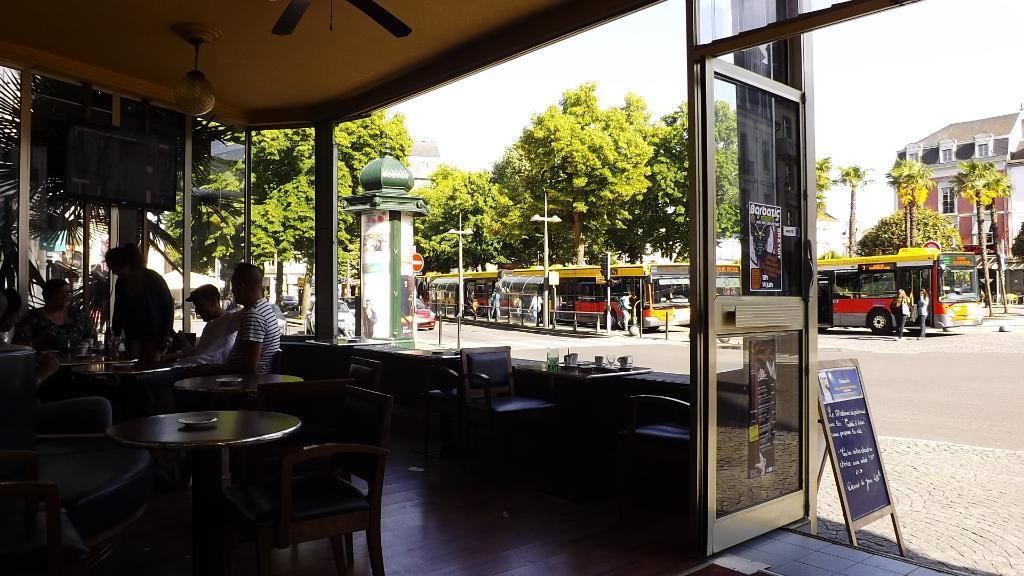How many people are in the image? There is a group of people in the image. What are the people doing in the image? The people are seated on chairs. How many chairs are visible in the image? There are chairs visible in the image. What type of furniture is also present in the image? There are tables in the image. What type of vegetation can be seen in the image? Bushes and trees are visible in the image. What type of structure is present in the image? There is a building in the image. How many elbows can be seen on the people in the image? There is no way to determine the number of elbows visible in the image, as it is not possible to see the underside of the people's arms. 